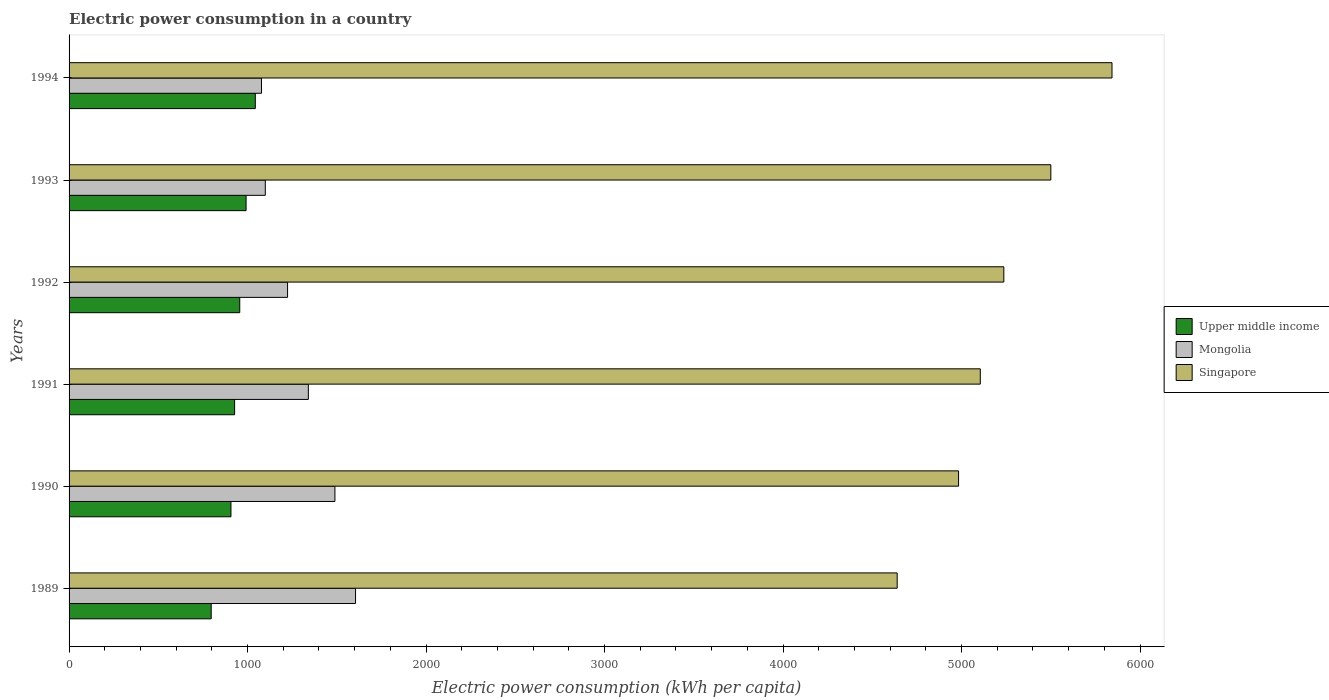Are the number of bars per tick equal to the number of legend labels?
Give a very brief answer. Yes. How many bars are there on the 5th tick from the bottom?
Provide a short and direct response. 3. What is the label of the 2nd group of bars from the top?
Give a very brief answer. 1993. In how many cases, is the number of bars for a given year not equal to the number of legend labels?
Ensure brevity in your answer.  0. What is the electric power consumption in in Singapore in 1993?
Provide a short and direct response. 5499.92. Across all years, what is the maximum electric power consumption in in Upper middle income?
Provide a succinct answer. 1043.37. Across all years, what is the minimum electric power consumption in in Mongolia?
Make the answer very short. 1077.84. In which year was the electric power consumption in in Mongolia maximum?
Your response must be concise. 1989. What is the total electric power consumption in in Mongolia in the graph?
Provide a short and direct response. 7835.81. What is the difference between the electric power consumption in in Upper middle income in 1992 and that in 1994?
Provide a succinct answer. -87.22. What is the difference between the electric power consumption in in Upper middle income in 1993 and the electric power consumption in in Singapore in 1989?
Keep it short and to the point. -3647.55. What is the average electric power consumption in in Singapore per year?
Provide a short and direct response. 5217.71. In the year 1991, what is the difference between the electric power consumption in in Upper middle income and electric power consumption in in Mongolia?
Your response must be concise. -413.04. In how many years, is the electric power consumption in in Singapore greater than 1800 kWh per capita?
Offer a very short reply. 6. What is the ratio of the electric power consumption in in Upper middle income in 1993 to that in 1994?
Ensure brevity in your answer.  0.95. What is the difference between the highest and the second highest electric power consumption in in Mongolia?
Provide a succinct answer. 115.48. What is the difference between the highest and the lowest electric power consumption in in Singapore?
Your response must be concise. 1203.45. What does the 2nd bar from the top in 1990 represents?
Provide a short and direct response. Mongolia. What does the 2nd bar from the bottom in 1989 represents?
Provide a succinct answer. Mongolia. Is it the case that in every year, the sum of the electric power consumption in in Upper middle income and electric power consumption in in Mongolia is greater than the electric power consumption in in Singapore?
Offer a terse response. No. How many bars are there?
Your response must be concise. 18. How many years are there in the graph?
Your answer should be compact. 6. What is the difference between two consecutive major ticks on the X-axis?
Your answer should be compact. 1000. Does the graph contain any zero values?
Make the answer very short. No. Does the graph contain grids?
Make the answer very short. No. How many legend labels are there?
Offer a terse response. 3. How are the legend labels stacked?
Offer a very short reply. Vertical. What is the title of the graph?
Your answer should be compact. Electric power consumption in a country. Does "Indonesia" appear as one of the legend labels in the graph?
Your answer should be very brief. No. What is the label or title of the X-axis?
Ensure brevity in your answer.  Electric power consumption (kWh per capita). What is the Electric power consumption (kWh per capita) in Upper middle income in 1989?
Ensure brevity in your answer.  796.19. What is the Electric power consumption (kWh per capita) of Mongolia in 1989?
Provide a short and direct response. 1604.85. What is the Electric power consumption (kWh per capita) of Singapore in 1989?
Provide a short and direct response. 4639.19. What is the Electric power consumption (kWh per capita) in Upper middle income in 1990?
Provide a succinct answer. 906.92. What is the Electric power consumption (kWh per capita) of Mongolia in 1990?
Your answer should be compact. 1489.37. What is the Electric power consumption (kWh per capita) of Singapore in 1990?
Provide a succinct answer. 4983.1. What is the Electric power consumption (kWh per capita) in Upper middle income in 1991?
Offer a terse response. 927.4. What is the Electric power consumption (kWh per capita) in Mongolia in 1991?
Keep it short and to the point. 1340.45. What is the Electric power consumption (kWh per capita) of Singapore in 1991?
Provide a succinct answer. 5104.78. What is the Electric power consumption (kWh per capita) in Upper middle income in 1992?
Your answer should be very brief. 956.15. What is the Electric power consumption (kWh per capita) in Mongolia in 1992?
Your answer should be very brief. 1223.98. What is the Electric power consumption (kWh per capita) of Singapore in 1992?
Provide a short and direct response. 5236.64. What is the Electric power consumption (kWh per capita) of Upper middle income in 1993?
Keep it short and to the point. 991.64. What is the Electric power consumption (kWh per capita) of Mongolia in 1993?
Your answer should be compact. 1099.33. What is the Electric power consumption (kWh per capita) in Singapore in 1993?
Your answer should be compact. 5499.92. What is the Electric power consumption (kWh per capita) in Upper middle income in 1994?
Your answer should be very brief. 1043.37. What is the Electric power consumption (kWh per capita) in Mongolia in 1994?
Your answer should be compact. 1077.84. What is the Electric power consumption (kWh per capita) in Singapore in 1994?
Provide a succinct answer. 5842.64. Across all years, what is the maximum Electric power consumption (kWh per capita) of Upper middle income?
Provide a succinct answer. 1043.37. Across all years, what is the maximum Electric power consumption (kWh per capita) in Mongolia?
Ensure brevity in your answer.  1604.85. Across all years, what is the maximum Electric power consumption (kWh per capita) in Singapore?
Offer a very short reply. 5842.64. Across all years, what is the minimum Electric power consumption (kWh per capita) of Upper middle income?
Make the answer very short. 796.19. Across all years, what is the minimum Electric power consumption (kWh per capita) of Mongolia?
Your response must be concise. 1077.84. Across all years, what is the minimum Electric power consumption (kWh per capita) of Singapore?
Offer a very short reply. 4639.19. What is the total Electric power consumption (kWh per capita) in Upper middle income in the graph?
Make the answer very short. 5621.67. What is the total Electric power consumption (kWh per capita) in Mongolia in the graph?
Provide a short and direct response. 7835.81. What is the total Electric power consumption (kWh per capita) of Singapore in the graph?
Ensure brevity in your answer.  3.13e+04. What is the difference between the Electric power consumption (kWh per capita) of Upper middle income in 1989 and that in 1990?
Provide a succinct answer. -110.74. What is the difference between the Electric power consumption (kWh per capita) of Mongolia in 1989 and that in 1990?
Offer a very short reply. 115.48. What is the difference between the Electric power consumption (kWh per capita) in Singapore in 1989 and that in 1990?
Offer a very short reply. -343.91. What is the difference between the Electric power consumption (kWh per capita) of Upper middle income in 1989 and that in 1991?
Your answer should be very brief. -131.21. What is the difference between the Electric power consumption (kWh per capita) of Mongolia in 1989 and that in 1991?
Your answer should be compact. 264.41. What is the difference between the Electric power consumption (kWh per capita) of Singapore in 1989 and that in 1991?
Make the answer very short. -465.59. What is the difference between the Electric power consumption (kWh per capita) in Upper middle income in 1989 and that in 1992?
Make the answer very short. -159.96. What is the difference between the Electric power consumption (kWh per capita) of Mongolia in 1989 and that in 1992?
Your answer should be very brief. 380.88. What is the difference between the Electric power consumption (kWh per capita) of Singapore in 1989 and that in 1992?
Make the answer very short. -597.45. What is the difference between the Electric power consumption (kWh per capita) in Upper middle income in 1989 and that in 1993?
Ensure brevity in your answer.  -195.45. What is the difference between the Electric power consumption (kWh per capita) in Mongolia in 1989 and that in 1993?
Give a very brief answer. 505.53. What is the difference between the Electric power consumption (kWh per capita) in Singapore in 1989 and that in 1993?
Your answer should be very brief. -860.74. What is the difference between the Electric power consumption (kWh per capita) in Upper middle income in 1989 and that in 1994?
Make the answer very short. -247.18. What is the difference between the Electric power consumption (kWh per capita) of Mongolia in 1989 and that in 1994?
Offer a terse response. 527.02. What is the difference between the Electric power consumption (kWh per capita) in Singapore in 1989 and that in 1994?
Your answer should be very brief. -1203.45. What is the difference between the Electric power consumption (kWh per capita) of Upper middle income in 1990 and that in 1991?
Offer a very short reply. -20.48. What is the difference between the Electric power consumption (kWh per capita) of Mongolia in 1990 and that in 1991?
Offer a terse response. 148.92. What is the difference between the Electric power consumption (kWh per capita) in Singapore in 1990 and that in 1991?
Your answer should be compact. -121.68. What is the difference between the Electric power consumption (kWh per capita) in Upper middle income in 1990 and that in 1992?
Offer a terse response. -49.22. What is the difference between the Electric power consumption (kWh per capita) in Mongolia in 1990 and that in 1992?
Keep it short and to the point. 265.39. What is the difference between the Electric power consumption (kWh per capita) in Singapore in 1990 and that in 1992?
Make the answer very short. -253.54. What is the difference between the Electric power consumption (kWh per capita) of Upper middle income in 1990 and that in 1993?
Your answer should be very brief. -84.72. What is the difference between the Electric power consumption (kWh per capita) in Mongolia in 1990 and that in 1993?
Your answer should be compact. 390.04. What is the difference between the Electric power consumption (kWh per capita) in Singapore in 1990 and that in 1993?
Your answer should be very brief. -516.83. What is the difference between the Electric power consumption (kWh per capita) in Upper middle income in 1990 and that in 1994?
Offer a terse response. -136.44. What is the difference between the Electric power consumption (kWh per capita) in Mongolia in 1990 and that in 1994?
Give a very brief answer. 411.53. What is the difference between the Electric power consumption (kWh per capita) of Singapore in 1990 and that in 1994?
Your response must be concise. -859.55. What is the difference between the Electric power consumption (kWh per capita) of Upper middle income in 1991 and that in 1992?
Offer a very short reply. -28.74. What is the difference between the Electric power consumption (kWh per capita) of Mongolia in 1991 and that in 1992?
Keep it short and to the point. 116.47. What is the difference between the Electric power consumption (kWh per capita) of Singapore in 1991 and that in 1992?
Keep it short and to the point. -131.85. What is the difference between the Electric power consumption (kWh per capita) of Upper middle income in 1991 and that in 1993?
Give a very brief answer. -64.24. What is the difference between the Electric power consumption (kWh per capita) in Mongolia in 1991 and that in 1993?
Offer a terse response. 241.12. What is the difference between the Electric power consumption (kWh per capita) in Singapore in 1991 and that in 1993?
Ensure brevity in your answer.  -395.14. What is the difference between the Electric power consumption (kWh per capita) in Upper middle income in 1991 and that in 1994?
Offer a very short reply. -115.97. What is the difference between the Electric power consumption (kWh per capita) of Mongolia in 1991 and that in 1994?
Make the answer very short. 262.61. What is the difference between the Electric power consumption (kWh per capita) of Singapore in 1991 and that in 1994?
Give a very brief answer. -737.86. What is the difference between the Electric power consumption (kWh per capita) in Upper middle income in 1992 and that in 1993?
Offer a terse response. -35.5. What is the difference between the Electric power consumption (kWh per capita) of Mongolia in 1992 and that in 1993?
Provide a succinct answer. 124.65. What is the difference between the Electric power consumption (kWh per capita) in Singapore in 1992 and that in 1993?
Your answer should be very brief. -263.29. What is the difference between the Electric power consumption (kWh per capita) in Upper middle income in 1992 and that in 1994?
Make the answer very short. -87.22. What is the difference between the Electric power consumption (kWh per capita) of Mongolia in 1992 and that in 1994?
Your response must be concise. 146.14. What is the difference between the Electric power consumption (kWh per capita) of Singapore in 1992 and that in 1994?
Offer a terse response. -606.01. What is the difference between the Electric power consumption (kWh per capita) in Upper middle income in 1993 and that in 1994?
Provide a short and direct response. -51.73. What is the difference between the Electric power consumption (kWh per capita) of Mongolia in 1993 and that in 1994?
Keep it short and to the point. 21.49. What is the difference between the Electric power consumption (kWh per capita) in Singapore in 1993 and that in 1994?
Your answer should be very brief. -342.72. What is the difference between the Electric power consumption (kWh per capita) in Upper middle income in 1989 and the Electric power consumption (kWh per capita) in Mongolia in 1990?
Your answer should be compact. -693.18. What is the difference between the Electric power consumption (kWh per capita) in Upper middle income in 1989 and the Electric power consumption (kWh per capita) in Singapore in 1990?
Provide a succinct answer. -4186.91. What is the difference between the Electric power consumption (kWh per capita) of Mongolia in 1989 and the Electric power consumption (kWh per capita) of Singapore in 1990?
Keep it short and to the point. -3378.25. What is the difference between the Electric power consumption (kWh per capita) of Upper middle income in 1989 and the Electric power consumption (kWh per capita) of Mongolia in 1991?
Provide a succinct answer. -544.26. What is the difference between the Electric power consumption (kWh per capita) in Upper middle income in 1989 and the Electric power consumption (kWh per capita) in Singapore in 1991?
Your answer should be compact. -4308.59. What is the difference between the Electric power consumption (kWh per capita) in Mongolia in 1989 and the Electric power consumption (kWh per capita) in Singapore in 1991?
Make the answer very short. -3499.93. What is the difference between the Electric power consumption (kWh per capita) of Upper middle income in 1989 and the Electric power consumption (kWh per capita) of Mongolia in 1992?
Your response must be concise. -427.79. What is the difference between the Electric power consumption (kWh per capita) of Upper middle income in 1989 and the Electric power consumption (kWh per capita) of Singapore in 1992?
Your answer should be compact. -4440.45. What is the difference between the Electric power consumption (kWh per capita) in Mongolia in 1989 and the Electric power consumption (kWh per capita) in Singapore in 1992?
Your answer should be compact. -3631.78. What is the difference between the Electric power consumption (kWh per capita) of Upper middle income in 1989 and the Electric power consumption (kWh per capita) of Mongolia in 1993?
Make the answer very short. -303.14. What is the difference between the Electric power consumption (kWh per capita) in Upper middle income in 1989 and the Electric power consumption (kWh per capita) in Singapore in 1993?
Keep it short and to the point. -4703.74. What is the difference between the Electric power consumption (kWh per capita) in Mongolia in 1989 and the Electric power consumption (kWh per capita) in Singapore in 1993?
Provide a short and direct response. -3895.07. What is the difference between the Electric power consumption (kWh per capita) of Upper middle income in 1989 and the Electric power consumption (kWh per capita) of Mongolia in 1994?
Ensure brevity in your answer.  -281.65. What is the difference between the Electric power consumption (kWh per capita) in Upper middle income in 1989 and the Electric power consumption (kWh per capita) in Singapore in 1994?
Give a very brief answer. -5046.46. What is the difference between the Electric power consumption (kWh per capita) in Mongolia in 1989 and the Electric power consumption (kWh per capita) in Singapore in 1994?
Offer a terse response. -4237.79. What is the difference between the Electric power consumption (kWh per capita) in Upper middle income in 1990 and the Electric power consumption (kWh per capita) in Mongolia in 1991?
Your response must be concise. -433.52. What is the difference between the Electric power consumption (kWh per capita) of Upper middle income in 1990 and the Electric power consumption (kWh per capita) of Singapore in 1991?
Your answer should be compact. -4197.86. What is the difference between the Electric power consumption (kWh per capita) in Mongolia in 1990 and the Electric power consumption (kWh per capita) in Singapore in 1991?
Your response must be concise. -3615.41. What is the difference between the Electric power consumption (kWh per capita) of Upper middle income in 1990 and the Electric power consumption (kWh per capita) of Mongolia in 1992?
Your answer should be very brief. -317.05. What is the difference between the Electric power consumption (kWh per capita) in Upper middle income in 1990 and the Electric power consumption (kWh per capita) in Singapore in 1992?
Make the answer very short. -4329.71. What is the difference between the Electric power consumption (kWh per capita) of Mongolia in 1990 and the Electric power consumption (kWh per capita) of Singapore in 1992?
Your response must be concise. -3747.27. What is the difference between the Electric power consumption (kWh per capita) of Upper middle income in 1990 and the Electric power consumption (kWh per capita) of Mongolia in 1993?
Provide a succinct answer. -192.4. What is the difference between the Electric power consumption (kWh per capita) of Upper middle income in 1990 and the Electric power consumption (kWh per capita) of Singapore in 1993?
Your response must be concise. -4593. What is the difference between the Electric power consumption (kWh per capita) of Mongolia in 1990 and the Electric power consumption (kWh per capita) of Singapore in 1993?
Ensure brevity in your answer.  -4010.55. What is the difference between the Electric power consumption (kWh per capita) in Upper middle income in 1990 and the Electric power consumption (kWh per capita) in Mongolia in 1994?
Provide a succinct answer. -170.91. What is the difference between the Electric power consumption (kWh per capita) of Upper middle income in 1990 and the Electric power consumption (kWh per capita) of Singapore in 1994?
Make the answer very short. -4935.72. What is the difference between the Electric power consumption (kWh per capita) in Mongolia in 1990 and the Electric power consumption (kWh per capita) in Singapore in 1994?
Offer a terse response. -4353.27. What is the difference between the Electric power consumption (kWh per capita) of Upper middle income in 1991 and the Electric power consumption (kWh per capita) of Mongolia in 1992?
Your answer should be compact. -296.58. What is the difference between the Electric power consumption (kWh per capita) in Upper middle income in 1991 and the Electric power consumption (kWh per capita) in Singapore in 1992?
Give a very brief answer. -4309.24. What is the difference between the Electric power consumption (kWh per capita) in Mongolia in 1991 and the Electric power consumption (kWh per capita) in Singapore in 1992?
Your answer should be very brief. -3896.19. What is the difference between the Electric power consumption (kWh per capita) of Upper middle income in 1991 and the Electric power consumption (kWh per capita) of Mongolia in 1993?
Offer a very short reply. -171.93. What is the difference between the Electric power consumption (kWh per capita) in Upper middle income in 1991 and the Electric power consumption (kWh per capita) in Singapore in 1993?
Ensure brevity in your answer.  -4572.52. What is the difference between the Electric power consumption (kWh per capita) in Mongolia in 1991 and the Electric power consumption (kWh per capita) in Singapore in 1993?
Offer a very short reply. -4159.48. What is the difference between the Electric power consumption (kWh per capita) in Upper middle income in 1991 and the Electric power consumption (kWh per capita) in Mongolia in 1994?
Ensure brevity in your answer.  -150.44. What is the difference between the Electric power consumption (kWh per capita) of Upper middle income in 1991 and the Electric power consumption (kWh per capita) of Singapore in 1994?
Offer a terse response. -4915.24. What is the difference between the Electric power consumption (kWh per capita) in Mongolia in 1991 and the Electric power consumption (kWh per capita) in Singapore in 1994?
Your answer should be compact. -4502.2. What is the difference between the Electric power consumption (kWh per capita) of Upper middle income in 1992 and the Electric power consumption (kWh per capita) of Mongolia in 1993?
Offer a terse response. -143.18. What is the difference between the Electric power consumption (kWh per capita) of Upper middle income in 1992 and the Electric power consumption (kWh per capita) of Singapore in 1993?
Provide a short and direct response. -4543.78. What is the difference between the Electric power consumption (kWh per capita) in Mongolia in 1992 and the Electric power consumption (kWh per capita) in Singapore in 1993?
Provide a short and direct response. -4275.95. What is the difference between the Electric power consumption (kWh per capita) in Upper middle income in 1992 and the Electric power consumption (kWh per capita) in Mongolia in 1994?
Give a very brief answer. -121.69. What is the difference between the Electric power consumption (kWh per capita) in Upper middle income in 1992 and the Electric power consumption (kWh per capita) in Singapore in 1994?
Offer a terse response. -4886.5. What is the difference between the Electric power consumption (kWh per capita) in Mongolia in 1992 and the Electric power consumption (kWh per capita) in Singapore in 1994?
Give a very brief answer. -4618.67. What is the difference between the Electric power consumption (kWh per capita) of Upper middle income in 1993 and the Electric power consumption (kWh per capita) of Mongolia in 1994?
Your response must be concise. -86.2. What is the difference between the Electric power consumption (kWh per capita) in Upper middle income in 1993 and the Electric power consumption (kWh per capita) in Singapore in 1994?
Your answer should be compact. -4851. What is the difference between the Electric power consumption (kWh per capita) of Mongolia in 1993 and the Electric power consumption (kWh per capita) of Singapore in 1994?
Offer a terse response. -4743.32. What is the average Electric power consumption (kWh per capita) of Upper middle income per year?
Offer a very short reply. 936.94. What is the average Electric power consumption (kWh per capita) of Mongolia per year?
Provide a succinct answer. 1305.97. What is the average Electric power consumption (kWh per capita) of Singapore per year?
Offer a terse response. 5217.71. In the year 1989, what is the difference between the Electric power consumption (kWh per capita) in Upper middle income and Electric power consumption (kWh per capita) in Mongolia?
Provide a short and direct response. -808.66. In the year 1989, what is the difference between the Electric power consumption (kWh per capita) in Upper middle income and Electric power consumption (kWh per capita) in Singapore?
Offer a terse response. -3843. In the year 1989, what is the difference between the Electric power consumption (kWh per capita) of Mongolia and Electric power consumption (kWh per capita) of Singapore?
Make the answer very short. -3034.34. In the year 1990, what is the difference between the Electric power consumption (kWh per capita) in Upper middle income and Electric power consumption (kWh per capita) in Mongolia?
Offer a very short reply. -582.45. In the year 1990, what is the difference between the Electric power consumption (kWh per capita) of Upper middle income and Electric power consumption (kWh per capita) of Singapore?
Your response must be concise. -4076.17. In the year 1990, what is the difference between the Electric power consumption (kWh per capita) of Mongolia and Electric power consumption (kWh per capita) of Singapore?
Your answer should be very brief. -3493.73. In the year 1991, what is the difference between the Electric power consumption (kWh per capita) of Upper middle income and Electric power consumption (kWh per capita) of Mongolia?
Give a very brief answer. -413.04. In the year 1991, what is the difference between the Electric power consumption (kWh per capita) in Upper middle income and Electric power consumption (kWh per capita) in Singapore?
Provide a succinct answer. -4177.38. In the year 1991, what is the difference between the Electric power consumption (kWh per capita) in Mongolia and Electric power consumption (kWh per capita) in Singapore?
Your answer should be compact. -3764.34. In the year 1992, what is the difference between the Electric power consumption (kWh per capita) in Upper middle income and Electric power consumption (kWh per capita) in Mongolia?
Offer a terse response. -267.83. In the year 1992, what is the difference between the Electric power consumption (kWh per capita) of Upper middle income and Electric power consumption (kWh per capita) of Singapore?
Your answer should be very brief. -4280.49. In the year 1992, what is the difference between the Electric power consumption (kWh per capita) of Mongolia and Electric power consumption (kWh per capita) of Singapore?
Offer a very short reply. -4012.66. In the year 1993, what is the difference between the Electric power consumption (kWh per capita) in Upper middle income and Electric power consumption (kWh per capita) in Mongolia?
Make the answer very short. -107.69. In the year 1993, what is the difference between the Electric power consumption (kWh per capita) in Upper middle income and Electric power consumption (kWh per capita) in Singapore?
Your answer should be very brief. -4508.28. In the year 1993, what is the difference between the Electric power consumption (kWh per capita) of Mongolia and Electric power consumption (kWh per capita) of Singapore?
Your response must be concise. -4400.6. In the year 1994, what is the difference between the Electric power consumption (kWh per capita) in Upper middle income and Electric power consumption (kWh per capita) in Mongolia?
Give a very brief answer. -34.47. In the year 1994, what is the difference between the Electric power consumption (kWh per capita) of Upper middle income and Electric power consumption (kWh per capita) of Singapore?
Give a very brief answer. -4799.28. In the year 1994, what is the difference between the Electric power consumption (kWh per capita) of Mongolia and Electric power consumption (kWh per capita) of Singapore?
Keep it short and to the point. -4764.81. What is the ratio of the Electric power consumption (kWh per capita) in Upper middle income in 1989 to that in 1990?
Ensure brevity in your answer.  0.88. What is the ratio of the Electric power consumption (kWh per capita) of Mongolia in 1989 to that in 1990?
Provide a succinct answer. 1.08. What is the ratio of the Electric power consumption (kWh per capita) of Upper middle income in 1989 to that in 1991?
Offer a very short reply. 0.86. What is the ratio of the Electric power consumption (kWh per capita) of Mongolia in 1989 to that in 1991?
Your answer should be compact. 1.2. What is the ratio of the Electric power consumption (kWh per capita) in Singapore in 1989 to that in 1991?
Offer a very short reply. 0.91. What is the ratio of the Electric power consumption (kWh per capita) in Upper middle income in 1989 to that in 1992?
Offer a terse response. 0.83. What is the ratio of the Electric power consumption (kWh per capita) in Mongolia in 1989 to that in 1992?
Provide a succinct answer. 1.31. What is the ratio of the Electric power consumption (kWh per capita) in Singapore in 1989 to that in 1992?
Keep it short and to the point. 0.89. What is the ratio of the Electric power consumption (kWh per capita) of Upper middle income in 1989 to that in 1993?
Your answer should be compact. 0.8. What is the ratio of the Electric power consumption (kWh per capita) of Mongolia in 1989 to that in 1993?
Provide a succinct answer. 1.46. What is the ratio of the Electric power consumption (kWh per capita) of Singapore in 1989 to that in 1993?
Keep it short and to the point. 0.84. What is the ratio of the Electric power consumption (kWh per capita) in Upper middle income in 1989 to that in 1994?
Offer a terse response. 0.76. What is the ratio of the Electric power consumption (kWh per capita) of Mongolia in 1989 to that in 1994?
Make the answer very short. 1.49. What is the ratio of the Electric power consumption (kWh per capita) of Singapore in 1989 to that in 1994?
Offer a very short reply. 0.79. What is the ratio of the Electric power consumption (kWh per capita) of Upper middle income in 1990 to that in 1991?
Offer a very short reply. 0.98. What is the ratio of the Electric power consumption (kWh per capita) in Mongolia in 1990 to that in 1991?
Provide a short and direct response. 1.11. What is the ratio of the Electric power consumption (kWh per capita) of Singapore in 1990 to that in 1991?
Make the answer very short. 0.98. What is the ratio of the Electric power consumption (kWh per capita) in Upper middle income in 1990 to that in 1992?
Keep it short and to the point. 0.95. What is the ratio of the Electric power consumption (kWh per capita) of Mongolia in 1990 to that in 1992?
Offer a very short reply. 1.22. What is the ratio of the Electric power consumption (kWh per capita) in Singapore in 1990 to that in 1992?
Ensure brevity in your answer.  0.95. What is the ratio of the Electric power consumption (kWh per capita) in Upper middle income in 1990 to that in 1993?
Provide a short and direct response. 0.91. What is the ratio of the Electric power consumption (kWh per capita) of Mongolia in 1990 to that in 1993?
Give a very brief answer. 1.35. What is the ratio of the Electric power consumption (kWh per capita) in Singapore in 1990 to that in 1993?
Ensure brevity in your answer.  0.91. What is the ratio of the Electric power consumption (kWh per capita) of Upper middle income in 1990 to that in 1994?
Your answer should be very brief. 0.87. What is the ratio of the Electric power consumption (kWh per capita) of Mongolia in 1990 to that in 1994?
Your response must be concise. 1.38. What is the ratio of the Electric power consumption (kWh per capita) of Singapore in 1990 to that in 1994?
Offer a terse response. 0.85. What is the ratio of the Electric power consumption (kWh per capita) of Upper middle income in 1991 to that in 1992?
Your response must be concise. 0.97. What is the ratio of the Electric power consumption (kWh per capita) of Mongolia in 1991 to that in 1992?
Your answer should be compact. 1.1. What is the ratio of the Electric power consumption (kWh per capita) in Singapore in 1991 to that in 1992?
Ensure brevity in your answer.  0.97. What is the ratio of the Electric power consumption (kWh per capita) in Upper middle income in 1991 to that in 1993?
Your response must be concise. 0.94. What is the ratio of the Electric power consumption (kWh per capita) in Mongolia in 1991 to that in 1993?
Your response must be concise. 1.22. What is the ratio of the Electric power consumption (kWh per capita) of Singapore in 1991 to that in 1993?
Make the answer very short. 0.93. What is the ratio of the Electric power consumption (kWh per capita) of Mongolia in 1991 to that in 1994?
Keep it short and to the point. 1.24. What is the ratio of the Electric power consumption (kWh per capita) in Singapore in 1991 to that in 1994?
Your response must be concise. 0.87. What is the ratio of the Electric power consumption (kWh per capita) in Upper middle income in 1992 to that in 1993?
Keep it short and to the point. 0.96. What is the ratio of the Electric power consumption (kWh per capita) of Mongolia in 1992 to that in 1993?
Provide a succinct answer. 1.11. What is the ratio of the Electric power consumption (kWh per capita) in Singapore in 1992 to that in 1993?
Your response must be concise. 0.95. What is the ratio of the Electric power consumption (kWh per capita) in Upper middle income in 1992 to that in 1994?
Make the answer very short. 0.92. What is the ratio of the Electric power consumption (kWh per capita) in Mongolia in 1992 to that in 1994?
Your response must be concise. 1.14. What is the ratio of the Electric power consumption (kWh per capita) of Singapore in 1992 to that in 1994?
Provide a short and direct response. 0.9. What is the ratio of the Electric power consumption (kWh per capita) in Upper middle income in 1993 to that in 1994?
Keep it short and to the point. 0.95. What is the ratio of the Electric power consumption (kWh per capita) of Mongolia in 1993 to that in 1994?
Provide a succinct answer. 1.02. What is the ratio of the Electric power consumption (kWh per capita) of Singapore in 1993 to that in 1994?
Give a very brief answer. 0.94. What is the difference between the highest and the second highest Electric power consumption (kWh per capita) in Upper middle income?
Offer a very short reply. 51.73. What is the difference between the highest and the second highest Electric power consumption (kWh per capita) in Mongolia?
Keep it short and to the point. 115.48. What is the difference between the highest and the second highest Electric power consumption (kWh per capita) in Singapore?
Your answer should be compact. 342.72. What is the difference between the highest and the lowest Electric power consumption (kWh per capita) in Upper middle income?
Provide a short and direct response. 247.18. What is the difference between the highest and the lowest Electric power consumption (kWh per capita) of Mongolia?
Keep it short and to the point. 527.02. What is the difference between the highest and the lowest Electric power consumption (kWh per capita) in Singapore?
Make the answer very short. 1203.45. 